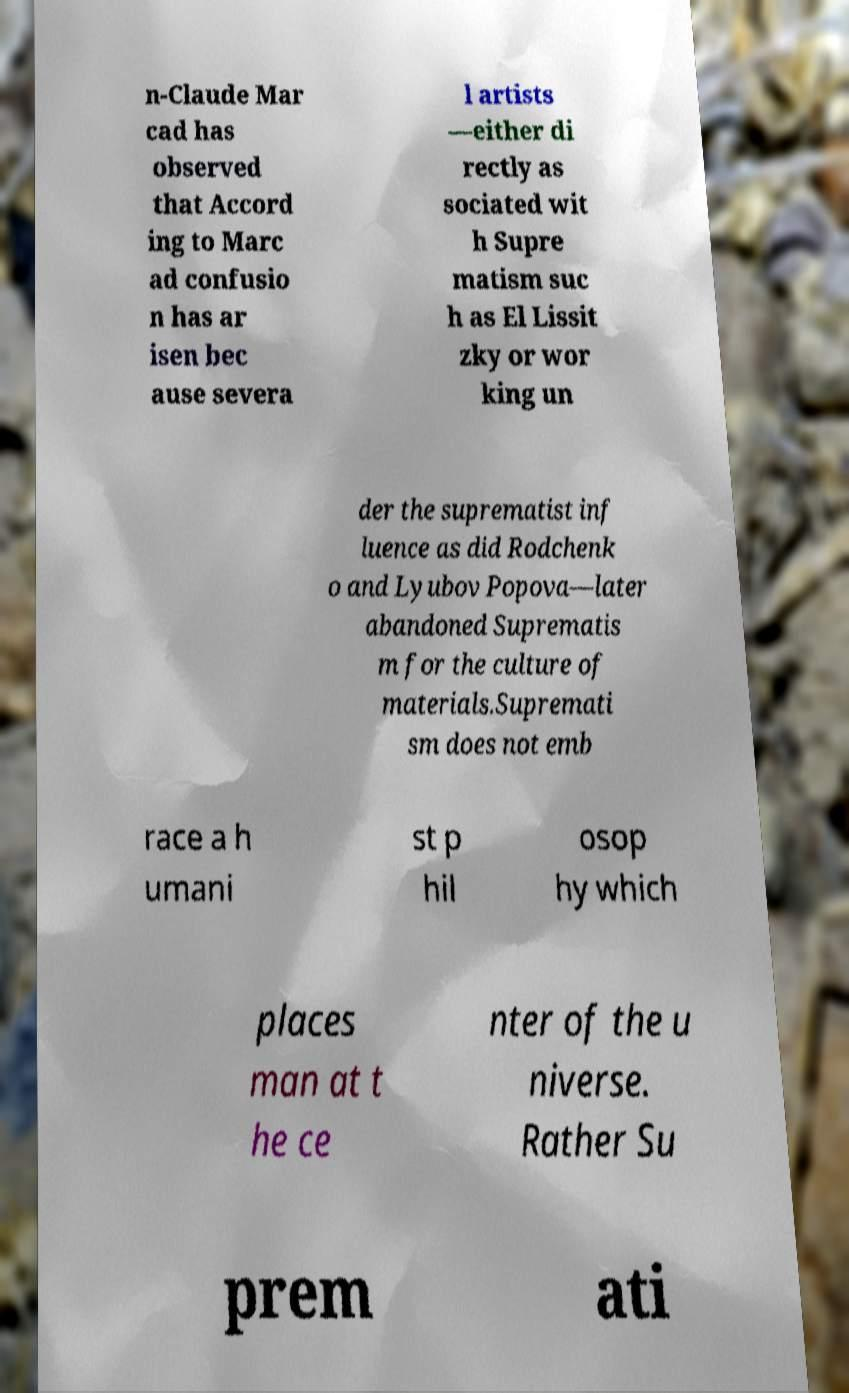What messages or text are displayed in this image? I need them in a readable, typed format. n-Claude Mar cad has observed that Accord ing to Marc ad confusio n has ar isen bec ause severa l artists —either di rectly as sociated wit h Supre matism suc h as El Lissit zky or wor king un der the suprematist inf luence as did Rodchenk o and Lyubov Popova—later abandoned Suprematis m for the culture of materials.Supremati sm does not emb race a h umani st p hil osop hy which places man at t he ce nter of the u niverse. Rather Su prem ati 